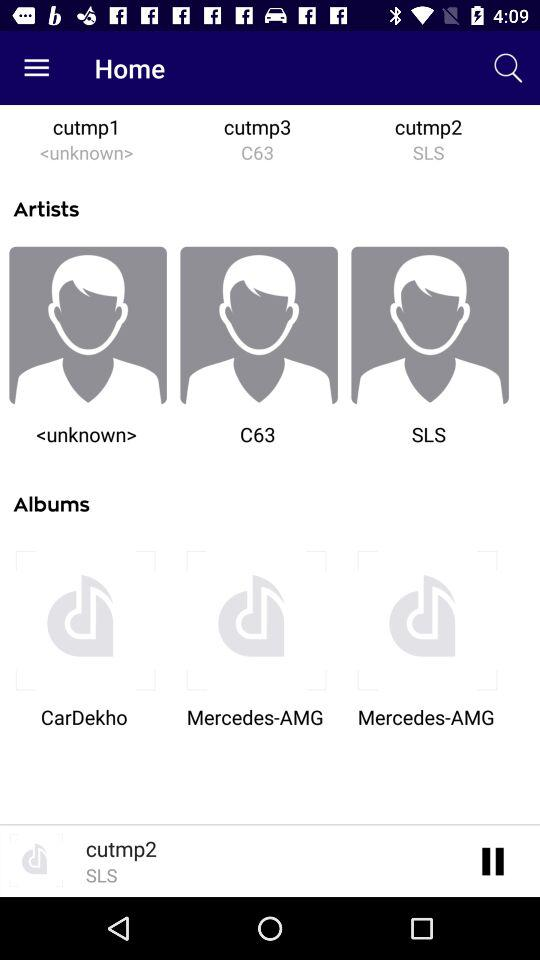Who are the different artists? The different artists are "<unknown>", "C63" and "SLS". 